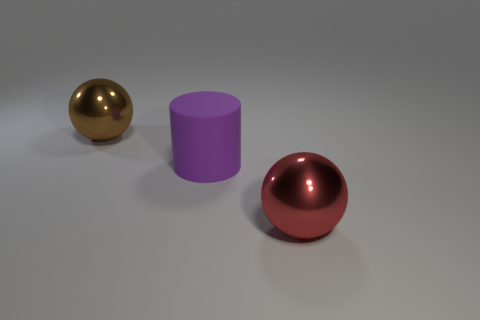What is the size of the other sphere that is the same material as the brown ball? Based on the image, it appears that there is only one sphere with a brown, presumably metallic, finish. The question seems to imply there is another sphere of the same material, but this is not visible in the image. If we are asked to compare the brown sphere with any other object in the frame, the closest comparison would be with the purple cylinder, which has a different shape and material, and thus cannot be directly compared in terms of size. 